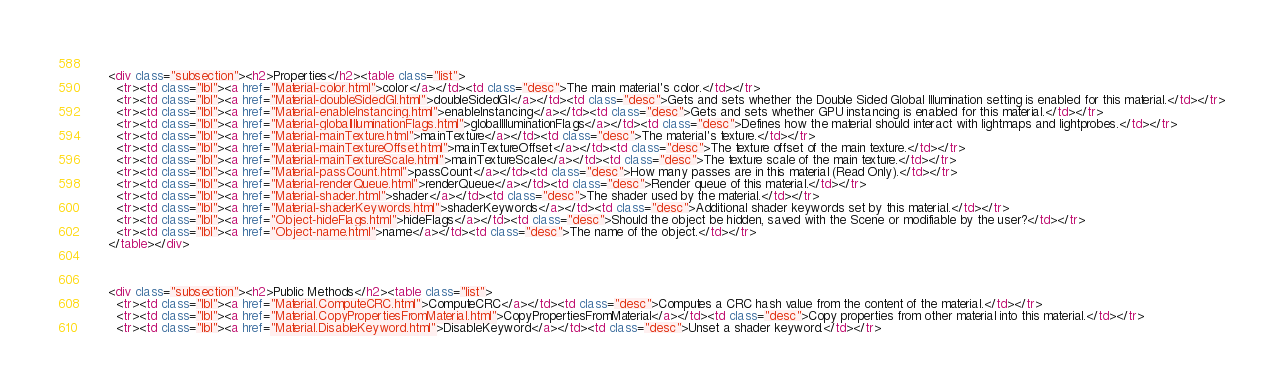Convert code to text. <code><loc_0><loc_0><loc_500><loc_500><_HTML_>      
      <div class="subsection"><h2>Properties</h2><table class="list">
        <tr><td class="lbl"><a href="Material-color.html">color</a></td><td class="desc">The main material's color.</td></tr>
        <tr><td class="lbl"><a href="Material-doubleSidedGI.html">doubleSidedGI</a></td><td class="desc">Gets and sets whether the Double Sided Global Illumination setting is enabled for this material.</td></tr>
        <tr><td class="lbl"><a href="Material-enableInstancing.html">enableInstancing</a></td><td class="desc">Gets and sets whether GPU instancing is enabled for this material.</td></tr>
        <tr><td class="lbl"><a href="Material-globalIlluminationFlags.html">globalIlluminationFlags</a></td><td class="desc">Defines how the material should interact with lightmaps and lightprobes.</td></tr>
        <tr><td class="lbl"><a href="Material-mainTexture.html">mainTexture</a></td><td class="desc">The material's texture.</td></tr>
        <tr><td class="lbl"><a href="Material-mainTextureOffset.html">mainTextureOffset</a></td><td class="desc">The texture offset of the main texture.</td></tr>
        <tr><td class="lbl"><a href="Material-mainTextureScale.html">mainTextureScale</a></td><td class="desc">The texture scale of the main texture.</td></tr>
        <tr><td class="lbl"><a href="Material-passCount.html">passCount</a></td><td class="desc">How many passes are in this material (Read Only).</td></tr>
        <tr><td class="lbl"><a href="Material-renderQueue.html">renderQueue</a></td><td class="desc">Render queue of this material.</td></tr>
        <tr><td class="lbl"><a href="Material-shader.html">shader</a></td><td class="desc">The shader used by the material.</td></tr>
        <tr><td class="lbl"><a href="Material-shaderKeywords.html">shaderKeywords</a></td><td class="desc">Additional shader keywords set by this material.</td></tr>
        <tr><td class="lbl"><a href="Object-hideFlags.html">hideFlags</a></td><td class="desc">Should the object be hidden, saved with the Scene or modifiable by the user?</td></tr>
        <tr><td class="lbl"><a href="Object-name.html">name</a></td><td class="desc">The name of the object.</td></tr>
      </table></div>
      
      
      
      <div class="subsection"><h2>Public Methods</h2><table class="list">
        <tr><td class="lbl"><a href="Material.ComputeCRC.html">ComputeCRC</a></td><td class="desc">Computes a CRC hash value from the content of the material.</td></tr>
        <tr><td class="lbl"><a href="Material.CopyPropertiesFromMaterial.html">CopyPropertiesFromMaterial</a></td><td class="desc">Copy properties from other material into this material.</td></tr>
        <tr><td class="lbl"><a href="Material.DisableKeyword.html">DisableKeyword</a></td><td class="desc">Unset a shader keyword.</td></tr></code> 